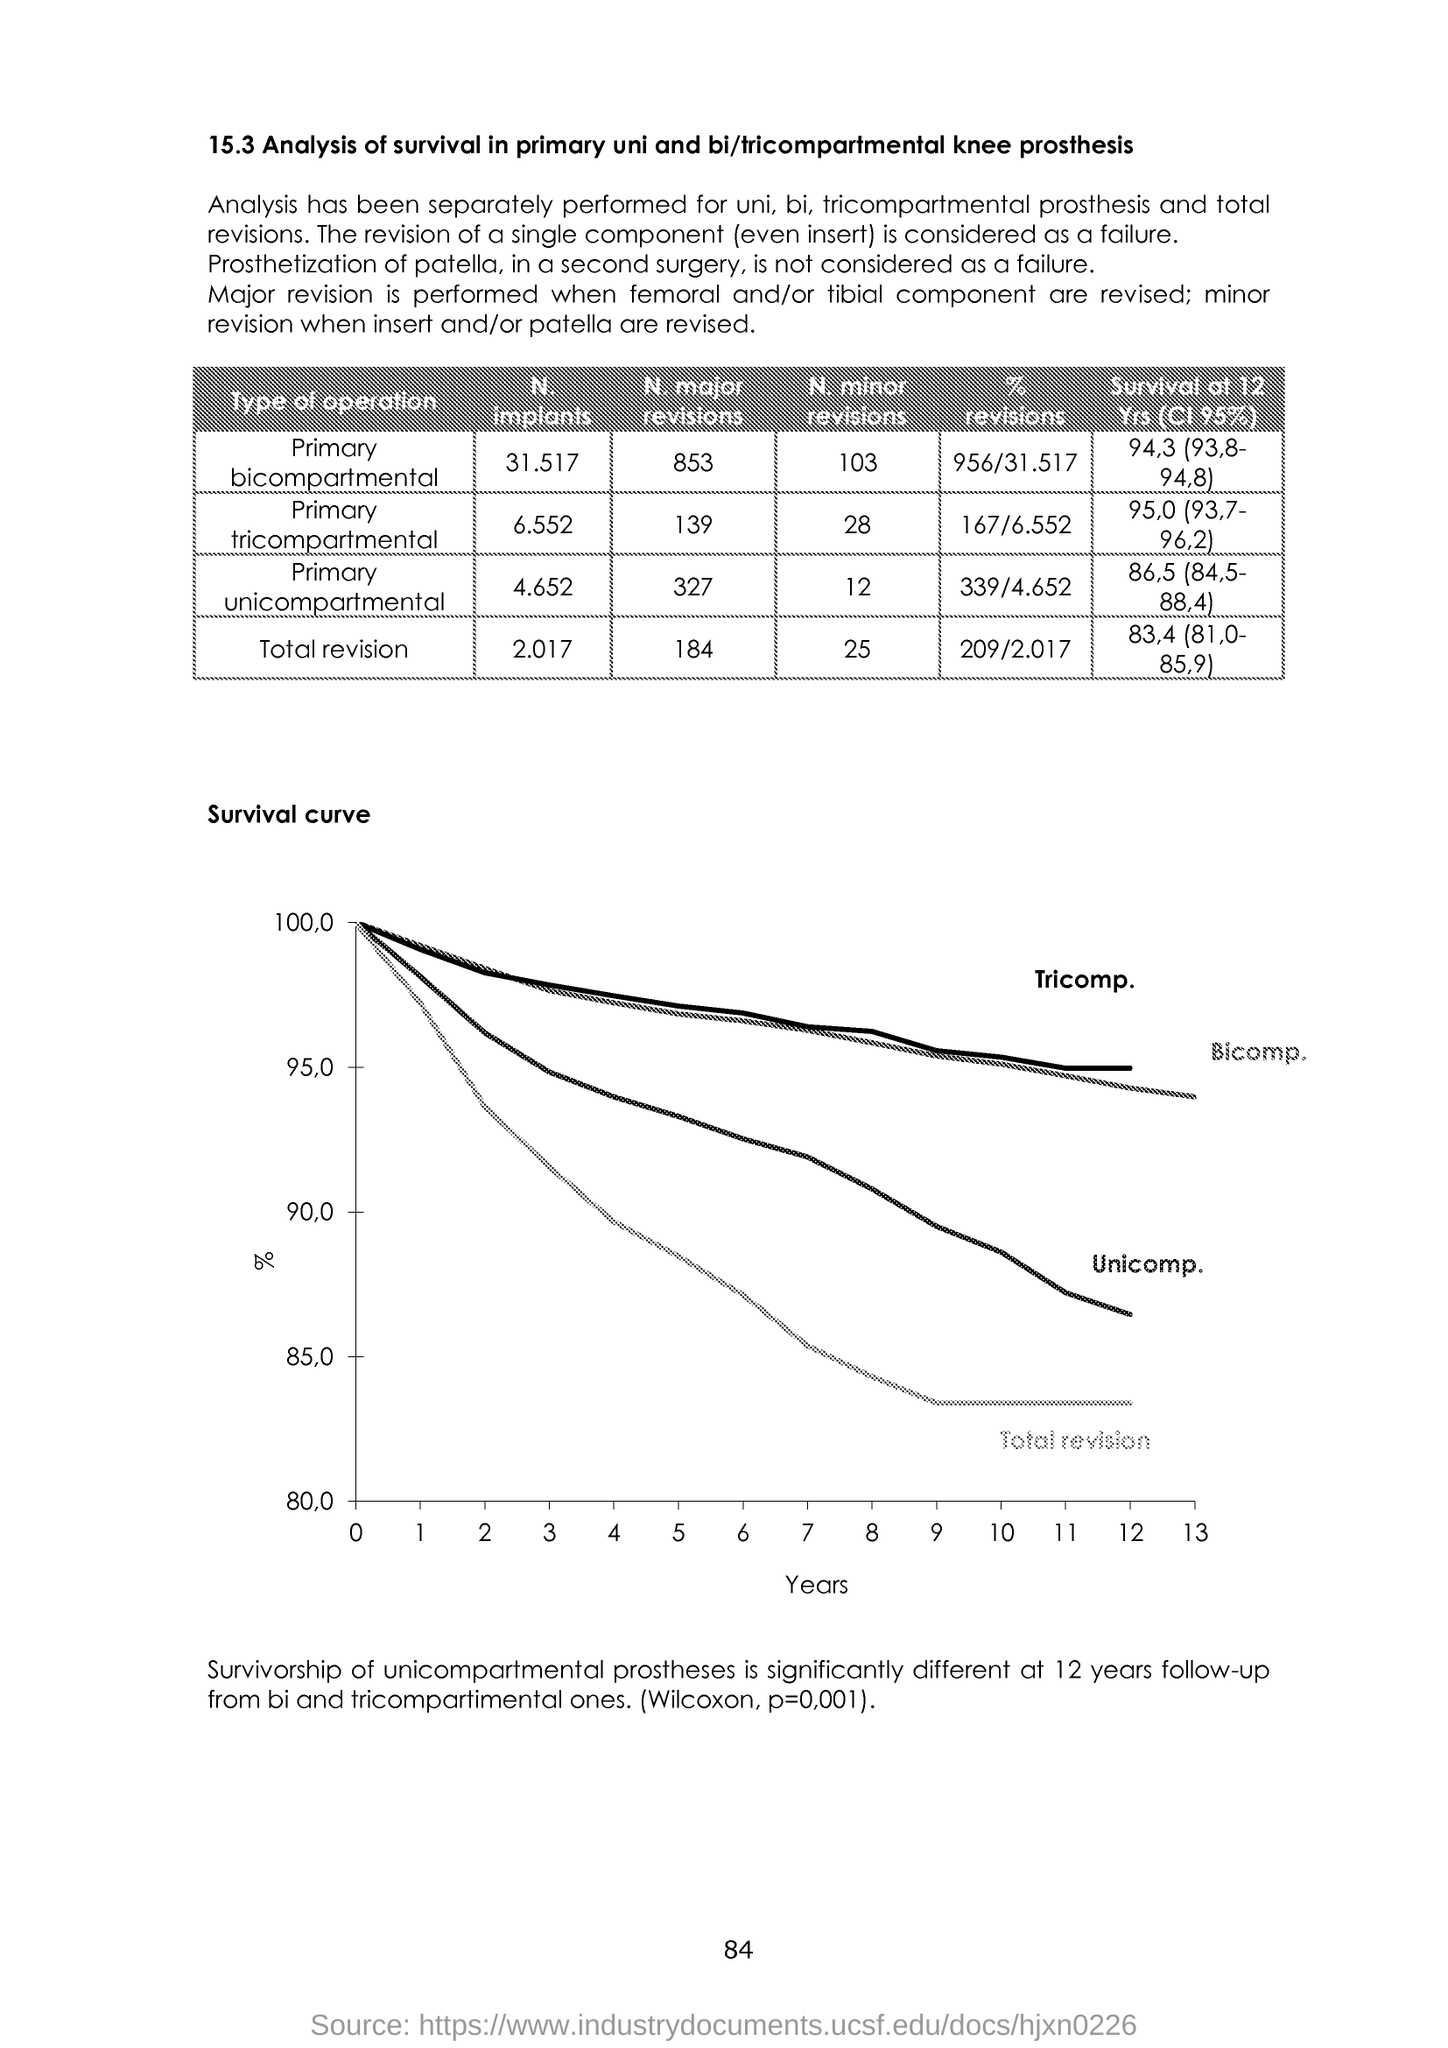Can you explain the significance of the 'Survivorship of unicompartmental prostheses' statement at the bottom? The statement at the bottom indicates that the survivability or success rate of unicompartmental knee prostheses is statistically different from bicompartmental and tricompartmental ones after a 12-year follow-up period. The reference to a Wilcoxon p-value of 0.001 suggests that this finding is highly statistically significant, meaning that it is very likely that the observed differences in survival rates between the prosthesis types are not due to random chance. 